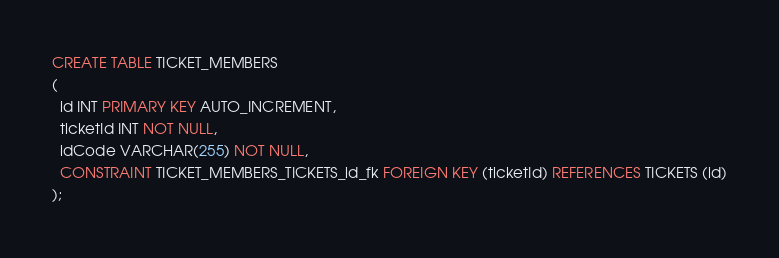<code> <loc_0><loc_0><loc_500><loc_500><_SQL_>CREATE TABLE TICKET_MEMBERS
(
  id INT PRIMARY KEY AUTO_INCREMENT,
  ticketId INT NOT NULL,
  idCode VARCHAR(255) NOT NULL,
  CONSTRAINT TICKET_MEMBERS_TICKETS_id_fk FOREIGN KEY (ticketId) REFERENCES TICKETS (id)
);</code> 